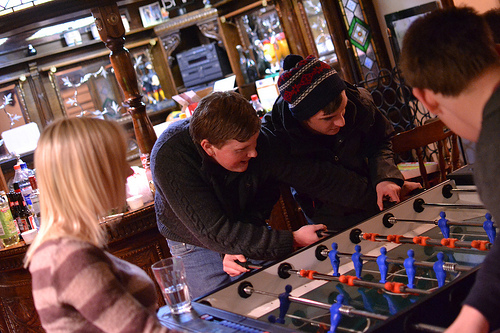<image>
Is the shelf behind the girl? No. The shelf is not behind the girl. From this viewpoint, the shelf appears to be positioned elsewhere in the scene. 